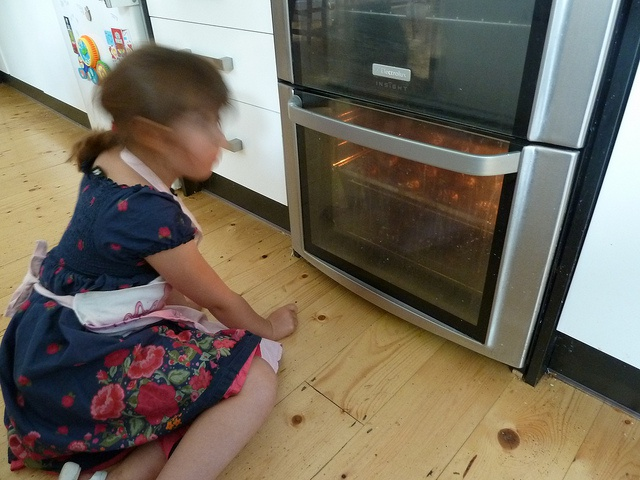Describe the objects in this image and their specific colors. I can see refrigerator in lightblue, black, gray, darkgray, and maroon tones, oven in lightblue, black, gray, darkgray, and maroon tones, people in lightblue, black, gray, maroon, and navy tones, and refrigerator in lightblue, white, darkgray, and darkgreen tones in this image. 